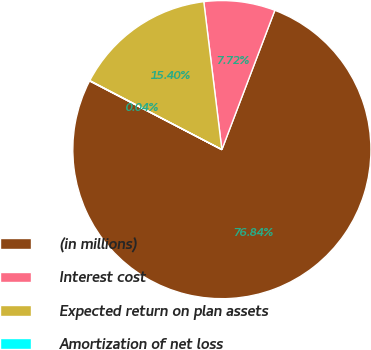<chart> <loc_0><loc_0><loc_500><loc_500><pie_chart><fcel>(in millions)<fcel>Interest cost<fcel>Expected return on plan assets<fcel>Amortization of net loss<nl><fcel>76.84%<fcel>7.72%<fcel>15.4%<fcel>0.04%<nl></chart> 